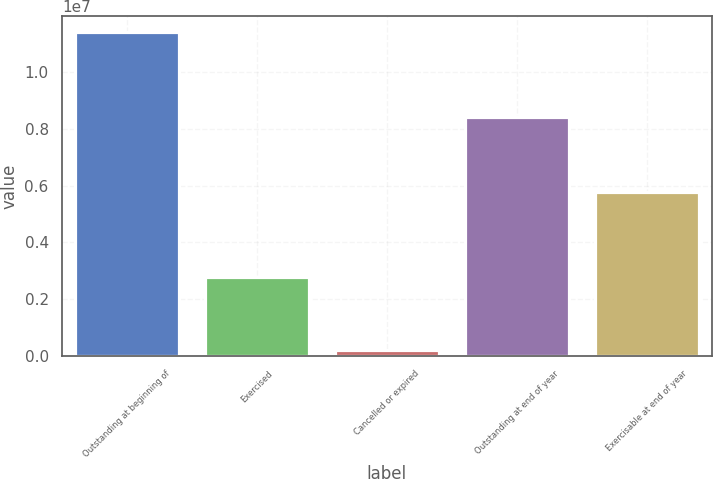<chart> <loc_0><loc_0><loc_500><loc_500><bar_chart><fcel>Outstanding at beginning of<fcel>Exercised<fcel>Cancelled or expired<fcel>Outstanding at end of year<fcel>Exercisable at end of year<nl><fcel>1.13959e+07<fcel>2.77057e+06<fcel>194000<fcel>8.43135e+06<fcel>5.77221e+06<nl></chart> 